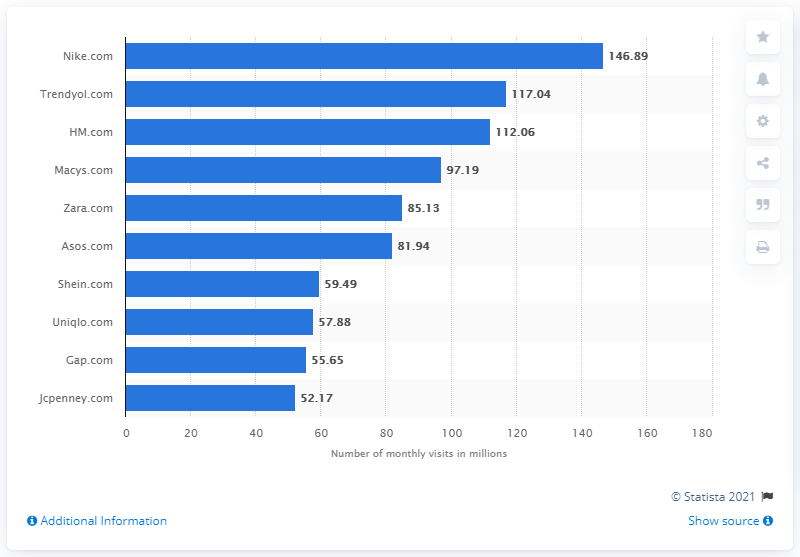Draw attention to some important aspects in this diagram. In 2020, the website with the highest number of visits in the fashion e-commerce category was Nike.com. According to data, Nike.com witnesses approximately 146.89 visitors per month. Trendyol.com is the largest e-commerce platform in Turkey. 